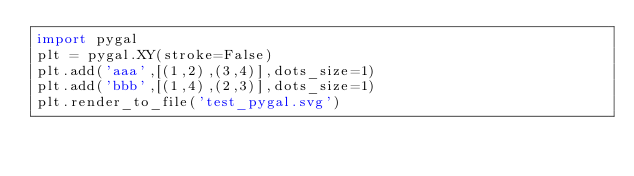<code> <loc_0><loc_0><loc_500><loc_500><_Python_>import pygal
plt = pygal.XY(stroke=False)
plt.add('aaa',[(1,2),(3,4)],dots_size=1)
plt.add('bbb',[(1,4),(2,3)],dots_size=1)
plt.render_to_file('test_pygal.svg')
</code> 